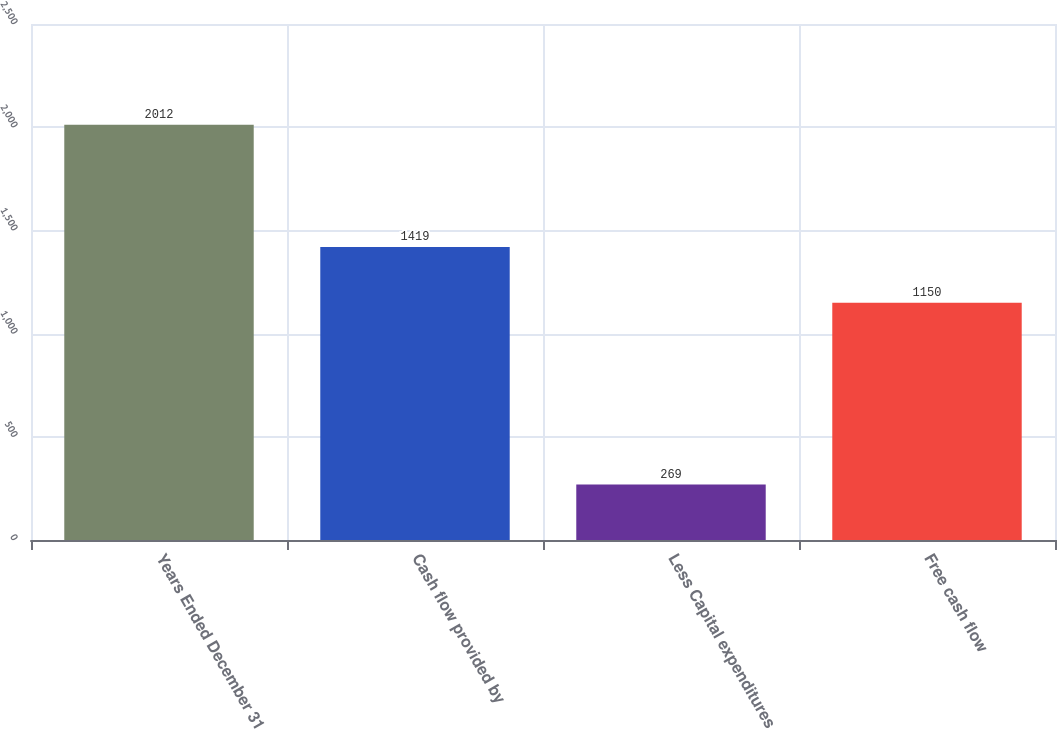Convert chart to OTSL. <chart><loc_0><loc_0><loc_500><loc_500><bar_chart><fcel>Years Ended December 31<fcel>Cash flow provided by<fcel>Less Capital expenditures<fcel>Free cash flow<nl><fcel>2012<fcel>1419<fcel>269<fcel>1150<nl></chart> 